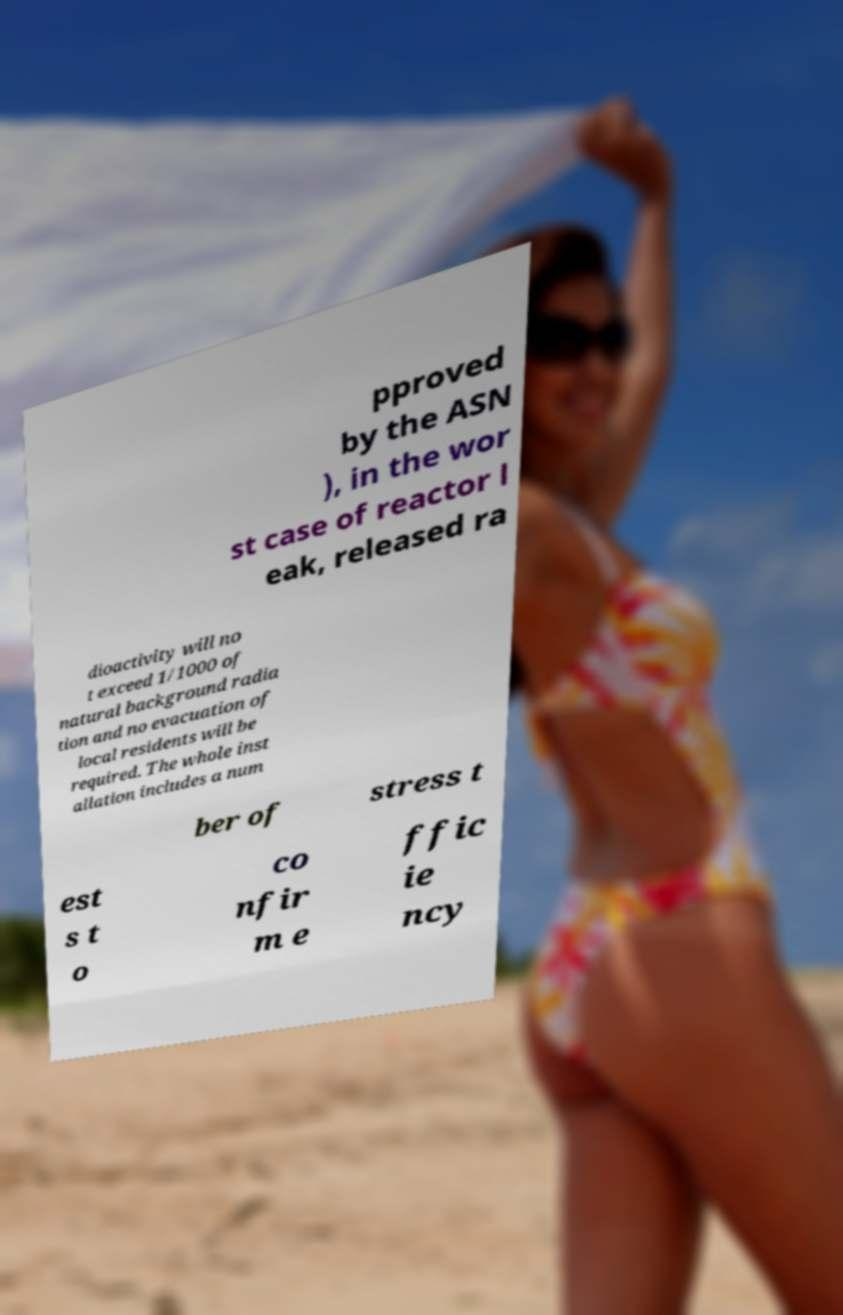Could you extract and type out the text from this image? pproved by the ASN ), in the wor st case of reactor l eak, released ra dioactivity will no t exceed 1/1000 of natural background radia tion and no evacuation of local residents will be required. The whole inst allation includes a num ber of stress t est s t o co nfir m e ffic ie ncy 